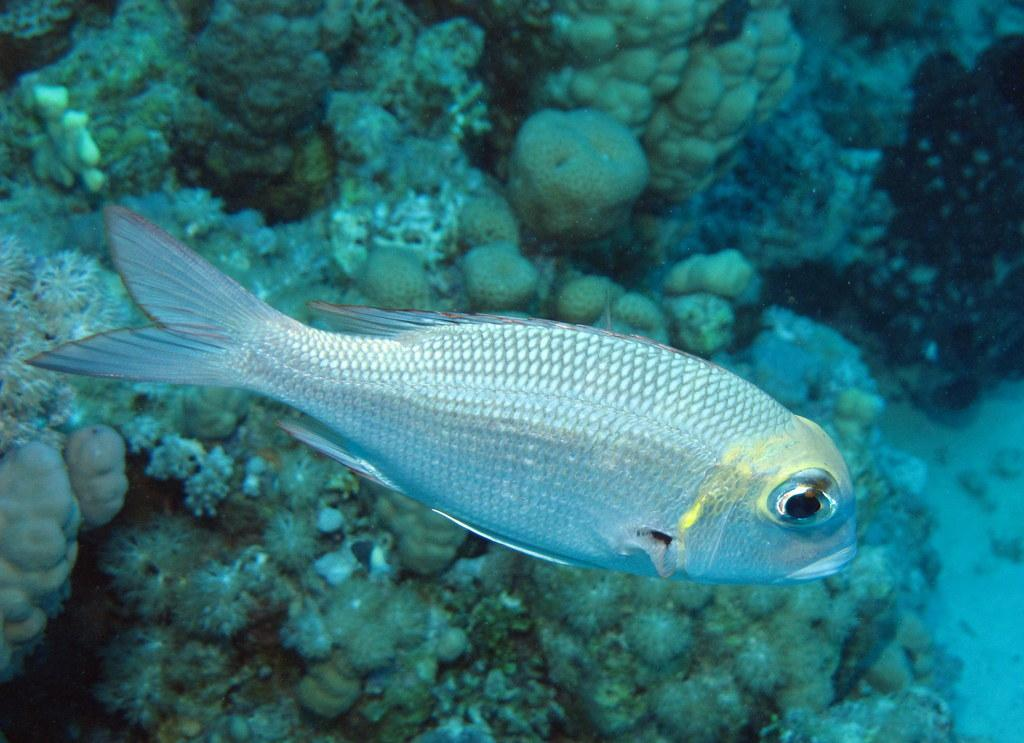What type of animal can be seen in the image? There is a fish in the image. What is the primary element in which the fish is situated? There is water visible in the image. What other objects can be seen in the image? There are stones in the image. What type of arm can be seen holding the fish in the image? There is no arm or person holding the fish in the image; it is situated in water with stones. 